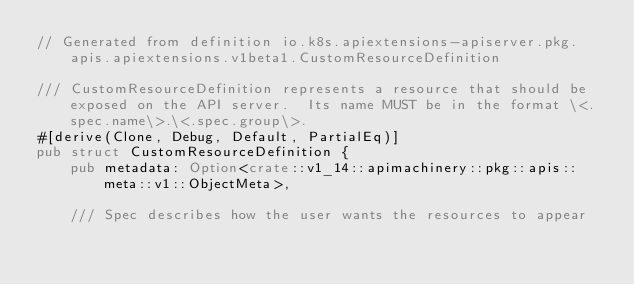Convert code to text. <code><loc_0><loc_0><loc_500><loc_500><_Rust_>// Generated from definition io.k8s.apiextensions-apiserver.pkg.apis.apiextensions.v1beta1.CustomResourceDefinition

/// CustomResourceDefinition represents a resource that should be exposed on the API server.  Its name MUST be in the format \<.spec.name\>.\<.spec.group\>.
#[derive(Clone, Debug, Default, PartialEq)]
pub struct CustomResourceDefinition {
    pub metadata: Option<crate::v1_14::apimachinery::pkg::apis::meta::v1::ObjectMeta>,

    /// Spec describes how the user wants the resources to appear</code> 